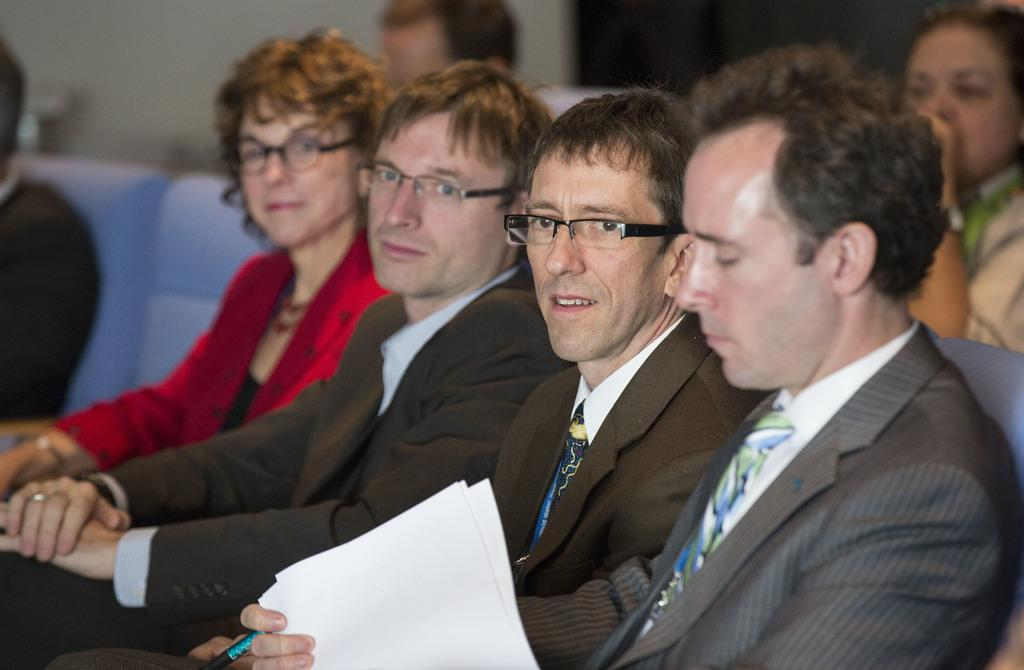What are the people in the image doing? The people in the image are sitting. What is the person on the right holding? The person on the right is holding papers and a pen. What can be seen in the background of the image? There is a wall in the background of the image. Is there a table in the image where the people are sitting? There is no table visible in the image. Can you see any smoke coming from the wall in the background? There is no smoke present in the image. 